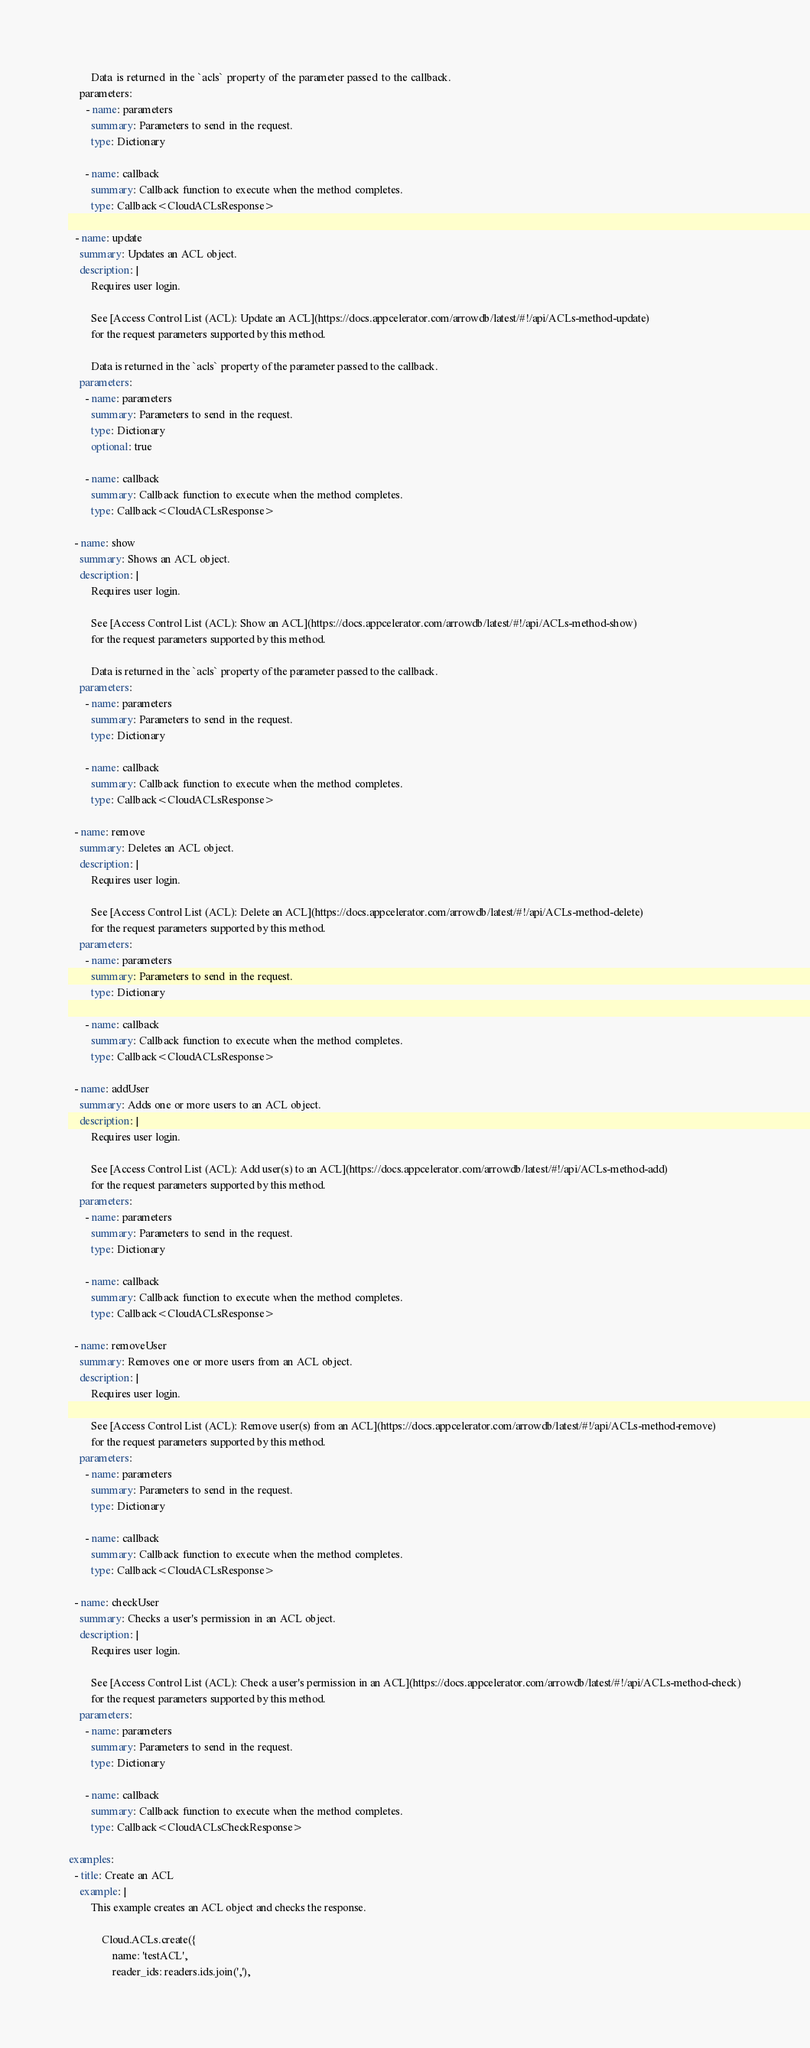Convert code to text. <code><loc_0><loc_0><loc_500><loc_500><_YAML_>
        Data is returned in the `acls` property of the parameter passed to the callback.
    parameters:
      - name: parameters
        summary: Parameters to send in the request.
        type: Dictionary

      - name: callback
        summary: Callback function to execute when the method completes.
        type: Callback<CloudACLsResponse>

  - name: update
    summary: Updates an ACL object.
    description: |
        Requires user login. 

        See [Access Control List (ACL): Update an ACL](https://docs.appcelerator.com/arrowdb/latest/#!/api/ACLs-method-update)
        for the request parameters supported by this method.

        Data is returned in the `acls` property of the parameter passed to the callback.
    parameters:
      - name: parameters
        summary: Parameters to send in the request.
        type: Dictionary
        optional: true

      - name: callback
        summary: Callback function to execute when the method completes.
        type: Callback<CloudACLsResponse>

  - name: show
    summary: Shows an ACL object.
    description: |
        Requires user login. 

        See [Access Control List (ACL): Show an ACL](https://docs.appcelerator.com/arrowdb/latest/#!/api/ACLs-method-show)
        for the request parameters supported by this method.

        Data is returned in the `acls` property of the parameter passed to the callback.
    parameters:
      - name: parameters
        summary: Parameters to send in the request.
        type: Dictionary

      - name: callback
        summary: Callback function to execute when the method completes.
        type: Callback<CloudACLsResponse>

  - name: remove
    summary: Deletes an ACL object.
    description: |
        Requires user login.

        See [Access Control List (ACL): Delete an ACL](https://docs.appcelerator.com/arrowdb/latest/#!/api/ACLs-method-delete)
        for the request parameters supported by this method.
    parameters:
      - name: parameters
        summary: Parameters to send in the request.
        type: Dictionary

      - name: callback
        summary: Callback function to execute when the method completes.
        type: Callback<CloudACLsResponse>

  - name: addUser
    summary: Adds one or more users to an ACL object.
    description: |
        Requires user login.

        See [Access Control List (ACL): Add user(s) to an ACL](https://docs.appcelerator.com/arrowdb/latest/#!/api/ACLs-method-add)
        for the request parameters supported by this method.
    parameters:
      - name: parameters
        summary: Parameters to send in the request.
        type: Dictionary

      - name: callback
        summary: Callback function to execute when the method completes.
        type: Callback<CloudACLsResponse>

  - name: removeUser
    summary: Removes one or more users from an ACL object.
    description: |
        Requires user login.

        See [Access Control List (ACL): Remove user(s) from an ACL](https://docs.appcelerator.com/arrowdb/latest/#!/api/ACLs-method-remove)
        for the request parameters supported by this method.
    parameters:
      - name: parameters
        summary: Parameters to send in the request.
        type: Dictionary

      - name: callback
        summary: Callback function to execute when the method completes.
        type: Callback<CloudACLsResponse>

  - name: checkUser
    summary: Checks a user's permission in an ACL object.
    description: |
        Requires user login.

        See [Access Control List (ACL): Check a user's permission in an ACL](https://docs.appcelerator.com/arrowdb/latest/#!/api/ACLs-method-check)
        for the request parameters supported by this method.
    parameters:
      - name: parameters
        summary: Parameters to send in the request.
        type: Dictionary

      - name: callback
        summary: Callback function to execute when the method completes.
        type: Callback<CloudACLsCheckResponse>

examples:
  - title: Create an ACL
    example: |
        This example creates an ACL object and checks the response.

            Cloud.ACLs.create({
                name: 'testACL',
                reader_ids: readers.ids.join(','),</code> 